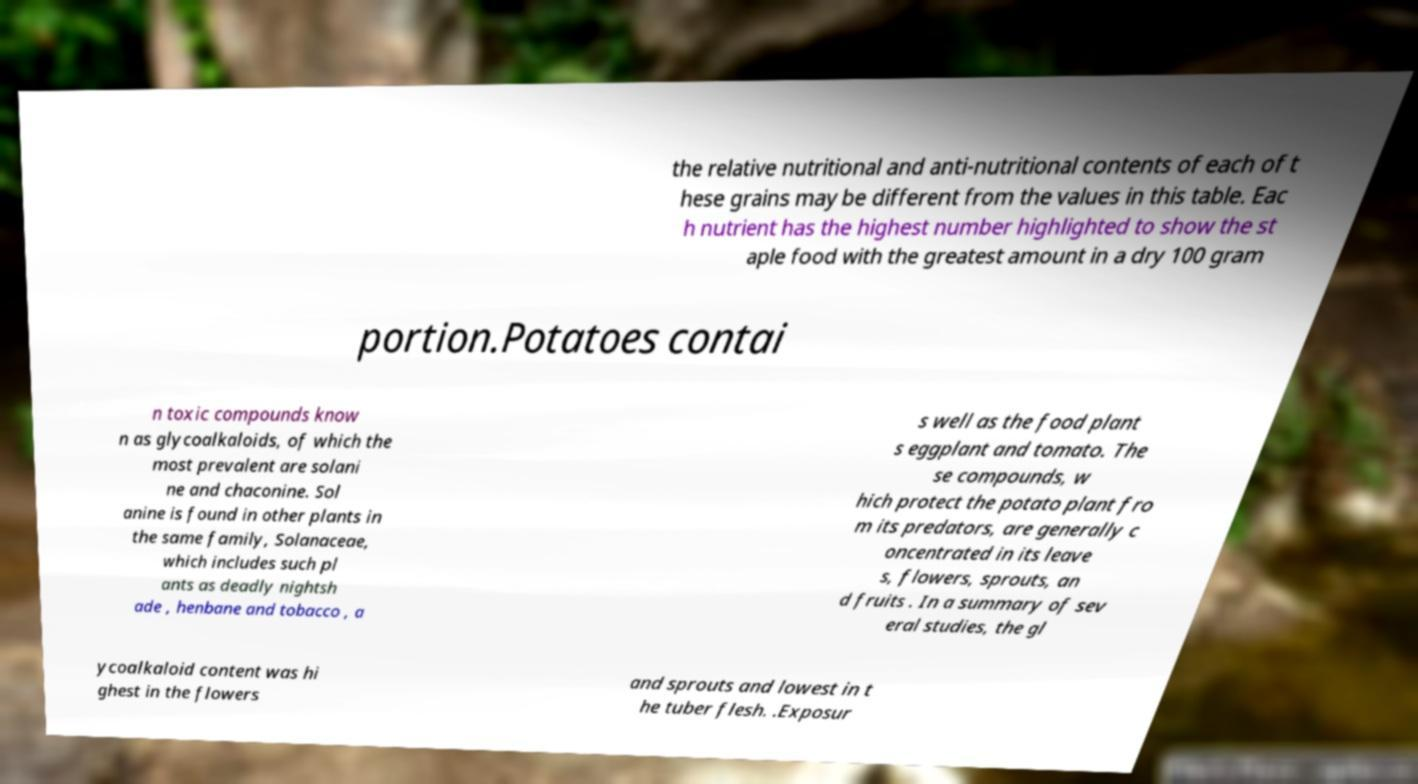There's text embedded in this image that I need extracted. Can you transcribe it verbatim? the relative nutritional and anti-nutritional contents of each of t hese grains may be different from the values in this table. Eac h nutrient has the highest number highlighted to show the st aple food with the greatest amount in a dry 100 gram portion.Potatoes contai n toxic compounds know n as glycoalkaloids, of which the most prevalent are solani ne and chaconine. Sol anine is found in other plants in the same family, Solanaceae, which includes such pl ants as deadly nightsh ade , henbane and tobacco , a s well as the food plant s eggplant and tomato. The se compounds, w hich protect the potato plant fro m its predators, are generally c oncentrated in its leave s, flowers, sprouts, an d fruits . In a summary of sev eral studies, the gl ycoalkaloid content was hi ghest in the flowers and sprouts and lowest in t he tuber flesh. .Exposur 